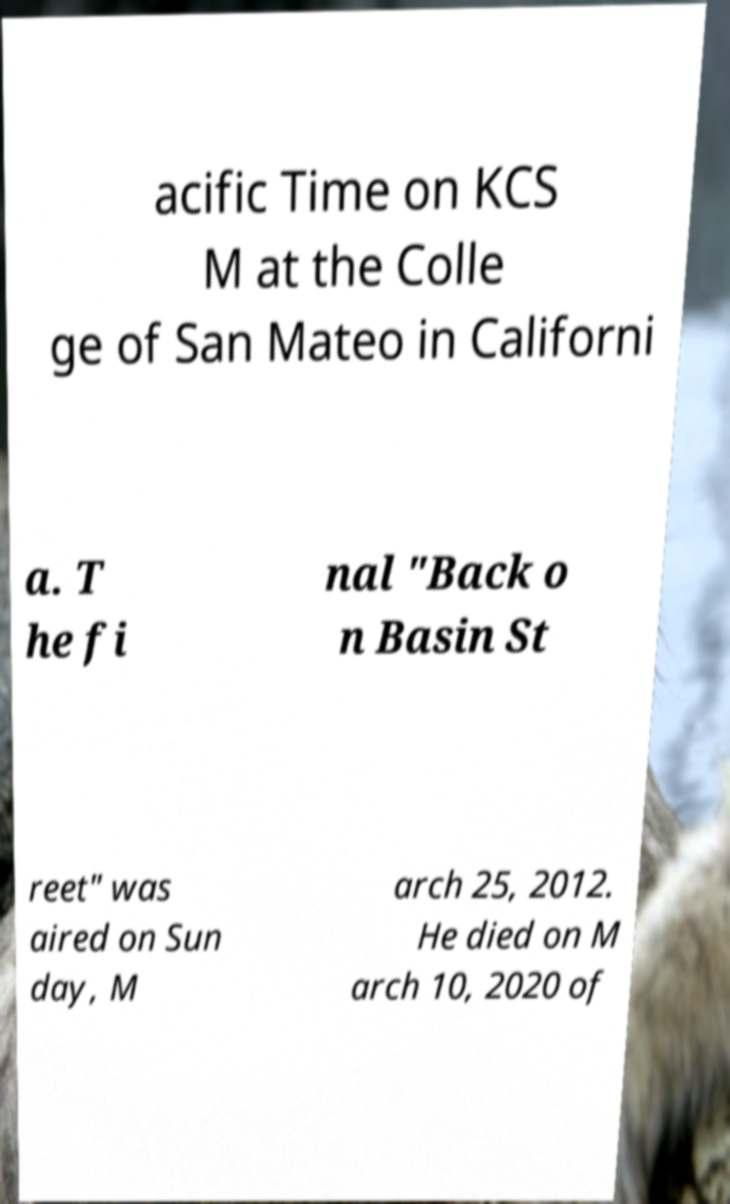Can you accurately transcribe the text from the provided image for me? acific Time on KCS M at the Colle ge of San Mateo in Californi a. T he fi nal "Back o n Basin St reet" was aired on Sun day, M arch 25, 2012. He died on M arch 10, 2020 of 